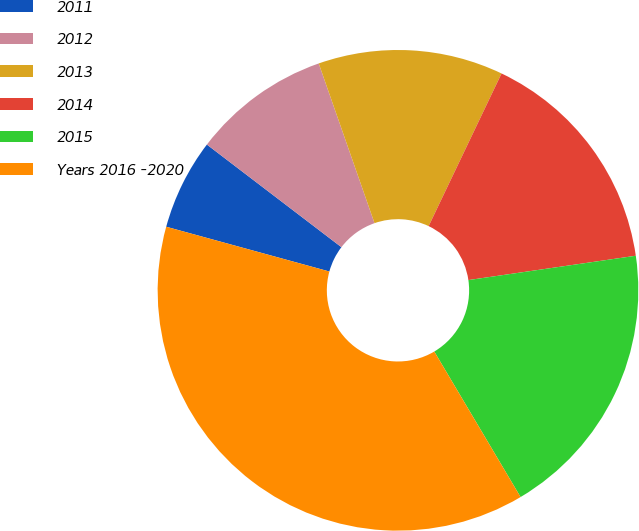Convert chart to OTSL. <chart><loc_0><loc_0><loc_500><loc_500><pie_chart><fcel>2011<fcel>2012<fcel>2013<fcel>2014<fcel>2015<fcel>Years 2016 -2020<nl><fcel>6.11%<fcel>9.28%<fcel>12.44%<fcel>15.61%<fcel>18.78%<fcel>37.78%<nl></chart> 